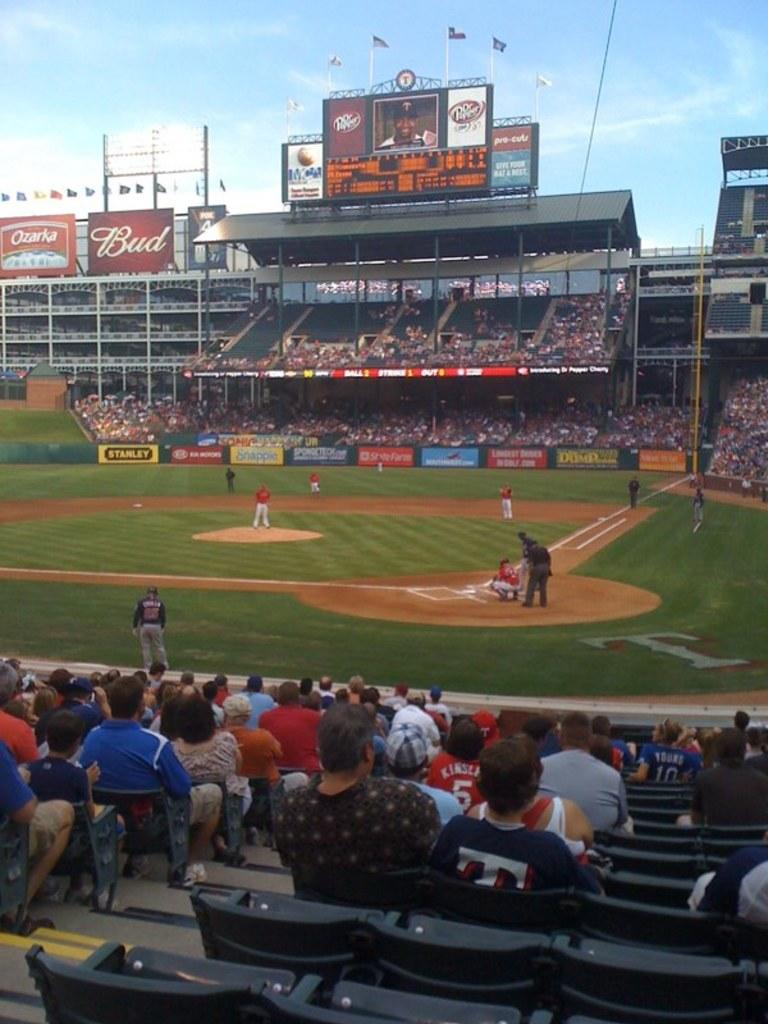<image>
Relay a brief, clear account of the picture shown. The brand being advertised above the scoreboard is Dr. Pepper 